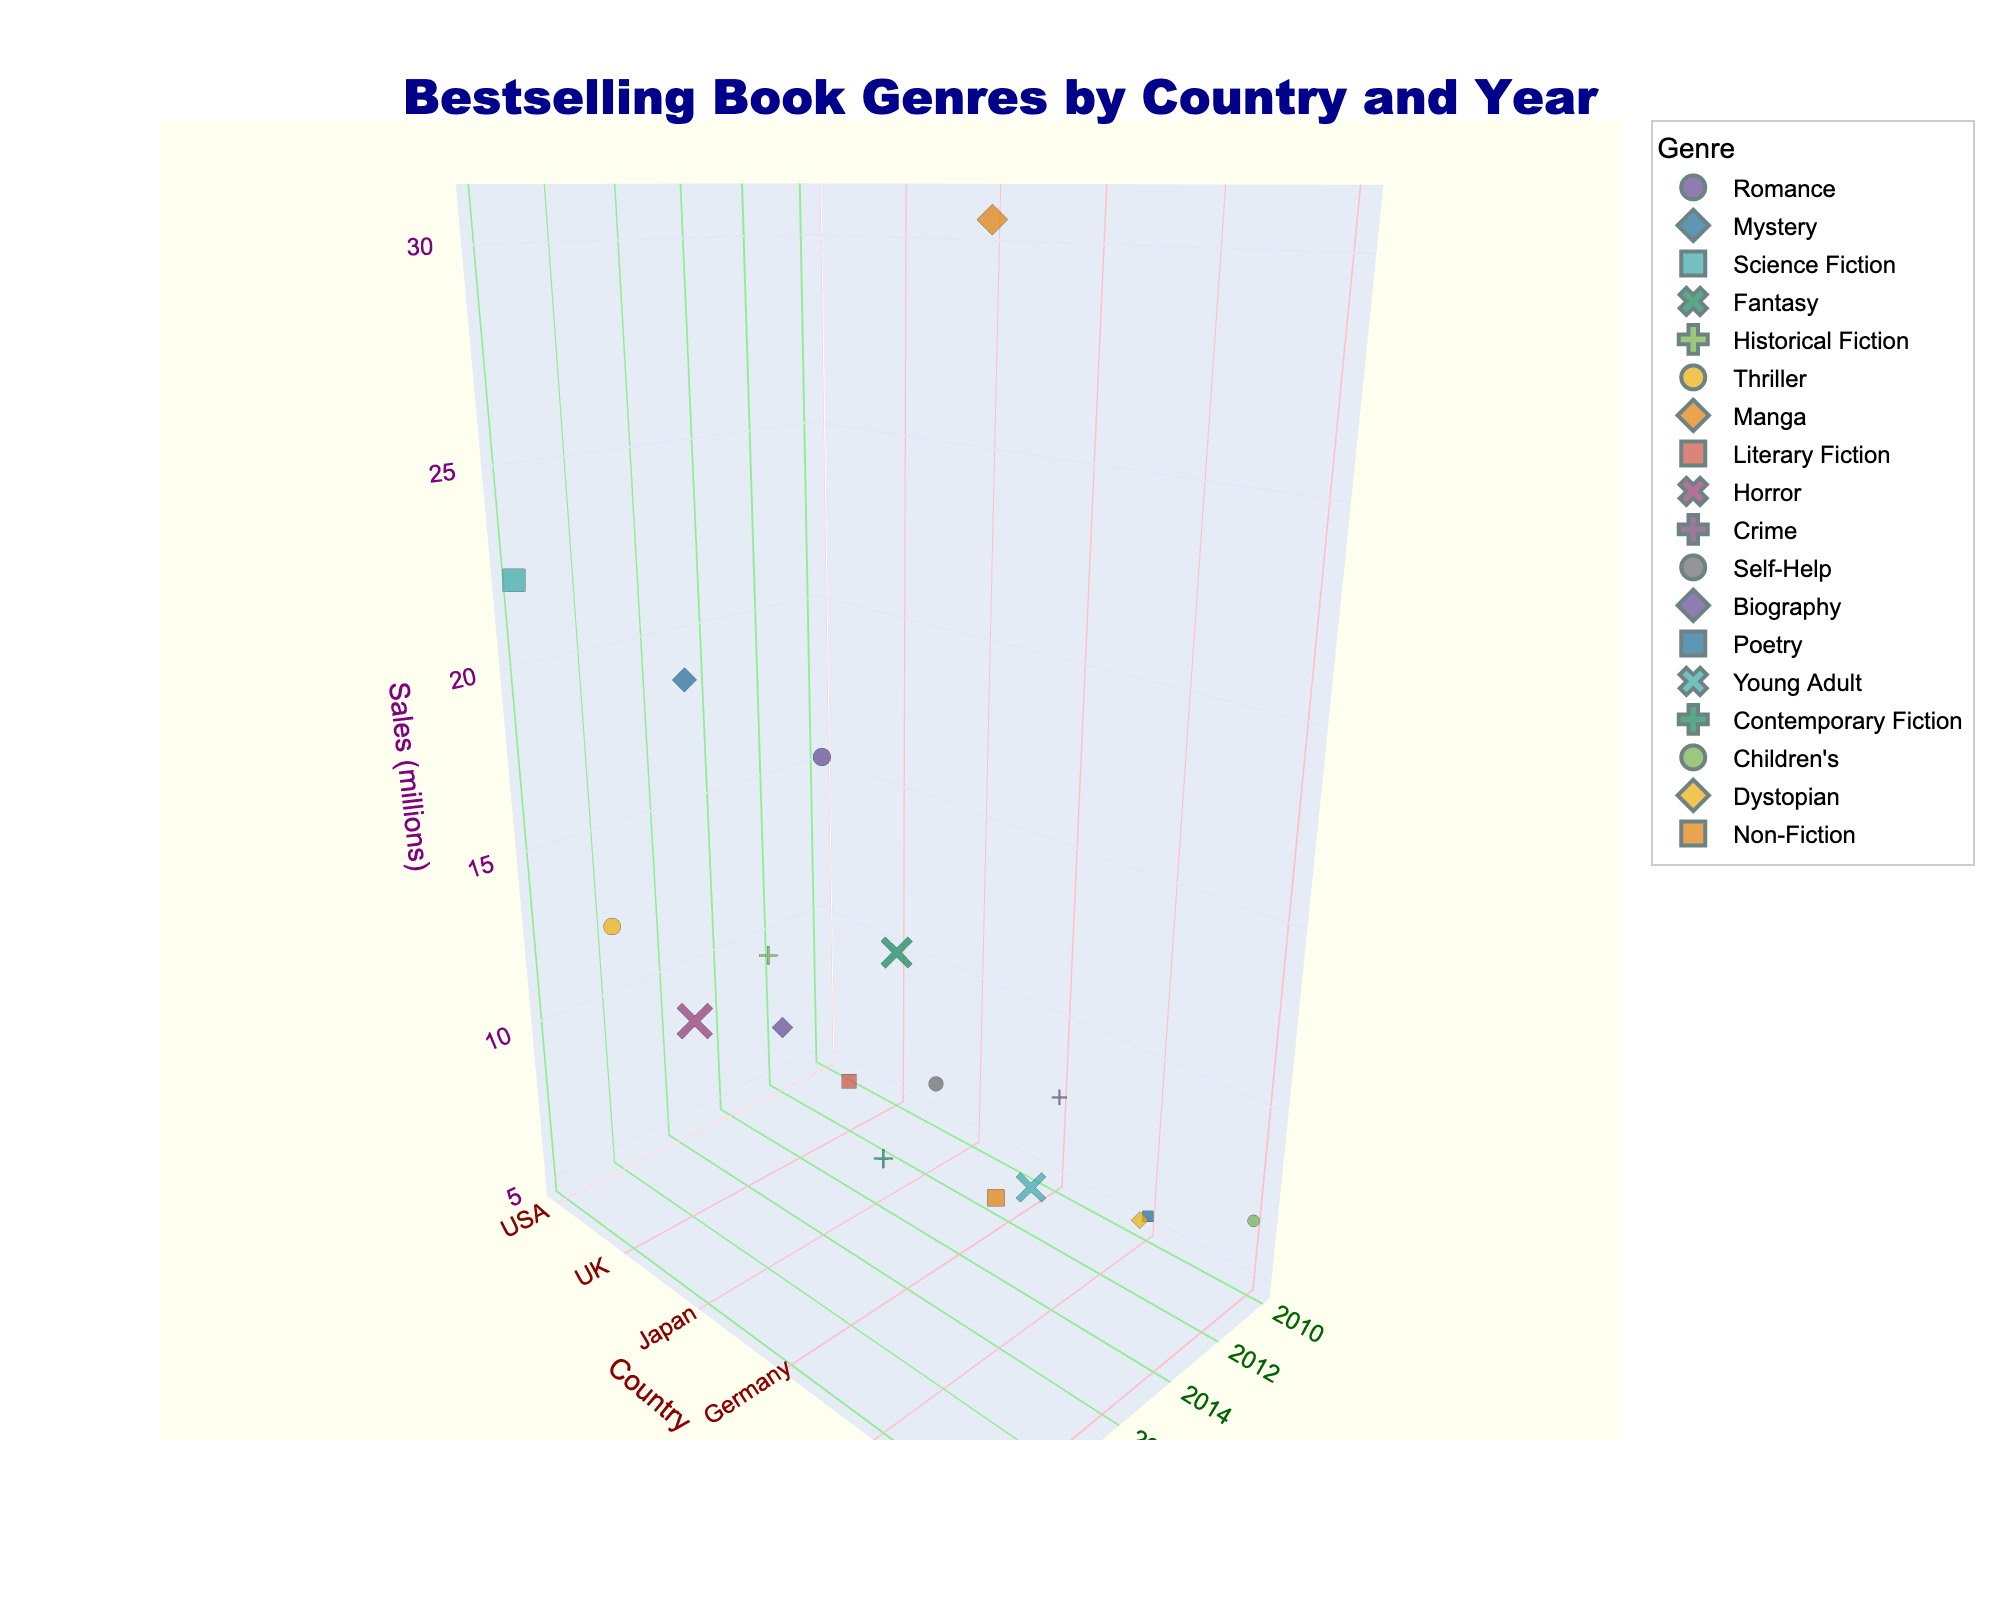How many countries are represented in the 3D plot? Count the distinct countries in the figure. The countries are USA, UK, Japan, Germany, France, and Australia.
Answer: 6 Which genre had the highest sales in 2020? Look at the 2020 data points and compare the sales values. Science Fiction in the USA has the highest sales with 22.3 million.
Answer: Science Fiction What is the total sales figure for Romance and Mystery genres combined in the USA? Look for the sales figures for Romance and Mystery in the USA and add them up. Romance: 15.2 million (2010), Mystery: 18.7 million (2015). 15.2 + 18.7 = 33.9 million.
Answer: 33.9 million Which country had the lowest sales of bestselling books in 2010? Examine the 2010 data points for each country. France had the lowest sales with 5.3 million in Poetry.
Answer: France How did the sales for France change from 2010 to 2020? Compare the sales in 2010 (Poetry: 5.3 million) and 2020 (Contemporary Fiction: 11.9 million) in France. Calculate the difference: 11.9 - 5.3 = 6.6 million.
Answer: Increased by 6.6 million In which year did Japan see a drop in sales compared to the previous recorded year, and what were the figures? Look at Japan's sales data for 2010 (Manga: 30.5 million), 2015 (Literary Fiction: 8.9 million), and 2020 (Horror: 12.7 million). Sales dropped from 30.5 million in 2010 to 8.9 million in 2015.
Answer: From 2010 to 2015, dropped by 21.6 million Which country had the highest sales in a single genre and what was it? Compare the sales figures across all genres and countries. Japan had the highest sales with Manga in 2010 at 30.5 million.
Answer: Japan, Manga Across all countries, which genre appeared the most frequently in the bestselling lists? Count the occurrence of each genre across all countries. Each genre appears only once, so there is no repetition.
Answer: No dominant genre How do the sales of Historical Fiction in the UK in 2015 compare to the sales of Self-Help in Germany in the same year? Compare the sales figures from the UK in 2015 (Historical Fiction: 11.5 million) and Germany in 2015 (Self-Help: 10.2 million). Historical Fiction has higher sales.
Answer: Historical Fiction is higher What trends can be observed from the sales data for the USA from 2010 to 2020? Observe the changes in sales figures for the USA over the years: 2010 (Romance: 15.2 million), 2015 (Mystery: 18.7 million), 2020 (Science Fiction: 22.3 million). The trend shows increasing sales over time.
Answer: Increasing sales 